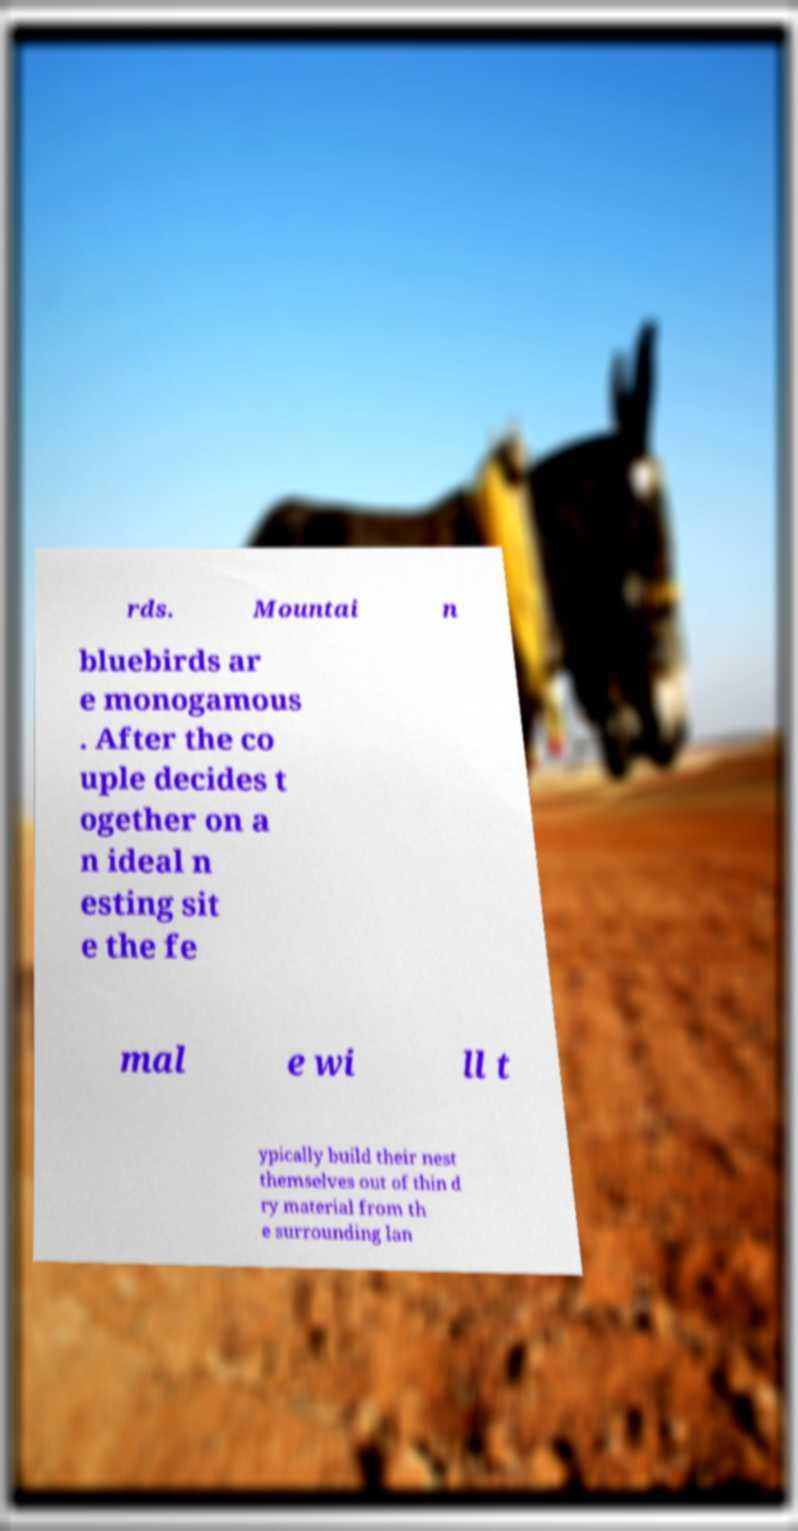Could you extract and type out the text from this image? rds. Mountai n bluebirds ar e monogamous . After the co uple decides t ogether on a n ideal n esting sit e the fe mal e wi ll t ypically build their nest themselves out of thin d ry material from th e surrounding lan 